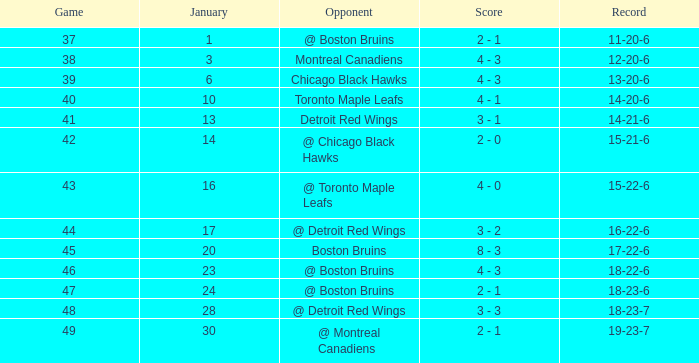Who was the opponent with the record of 15-21-6? @ Chicago Black Hawks. 